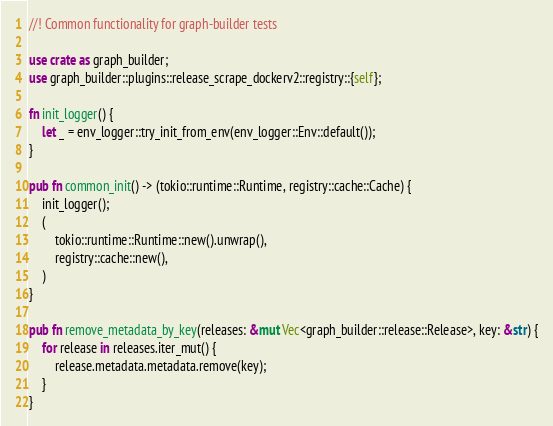Convert code to text. <code><loc_0><loc_0><loc_500><loc_500><_Rust_>//! Common functionality for graph-builder tests

use crate as graph_builder;
use graph_builder::plugins::release_scrape_dockerv2::registry::{self};

fn init_logger() {
    let _ = env_logger::try_init_from_env(env_logger::Env::default());
}

pub fn common_init() -> (tokio::runtime::Runtime, registry::cache::Cache) {
    init_logger();
    (
        tokio::runtime::Runtime::new().unwrap(),
        registry::cache::new(),
    )
}

pub fn remove_metadata_by_key(releases: &mut Vec<graph_builder::release::Release>, key: &str) {
    for release in releases.iter_mut() {
        release.metadata.metadata.remove(key);
    }
}
</code> 